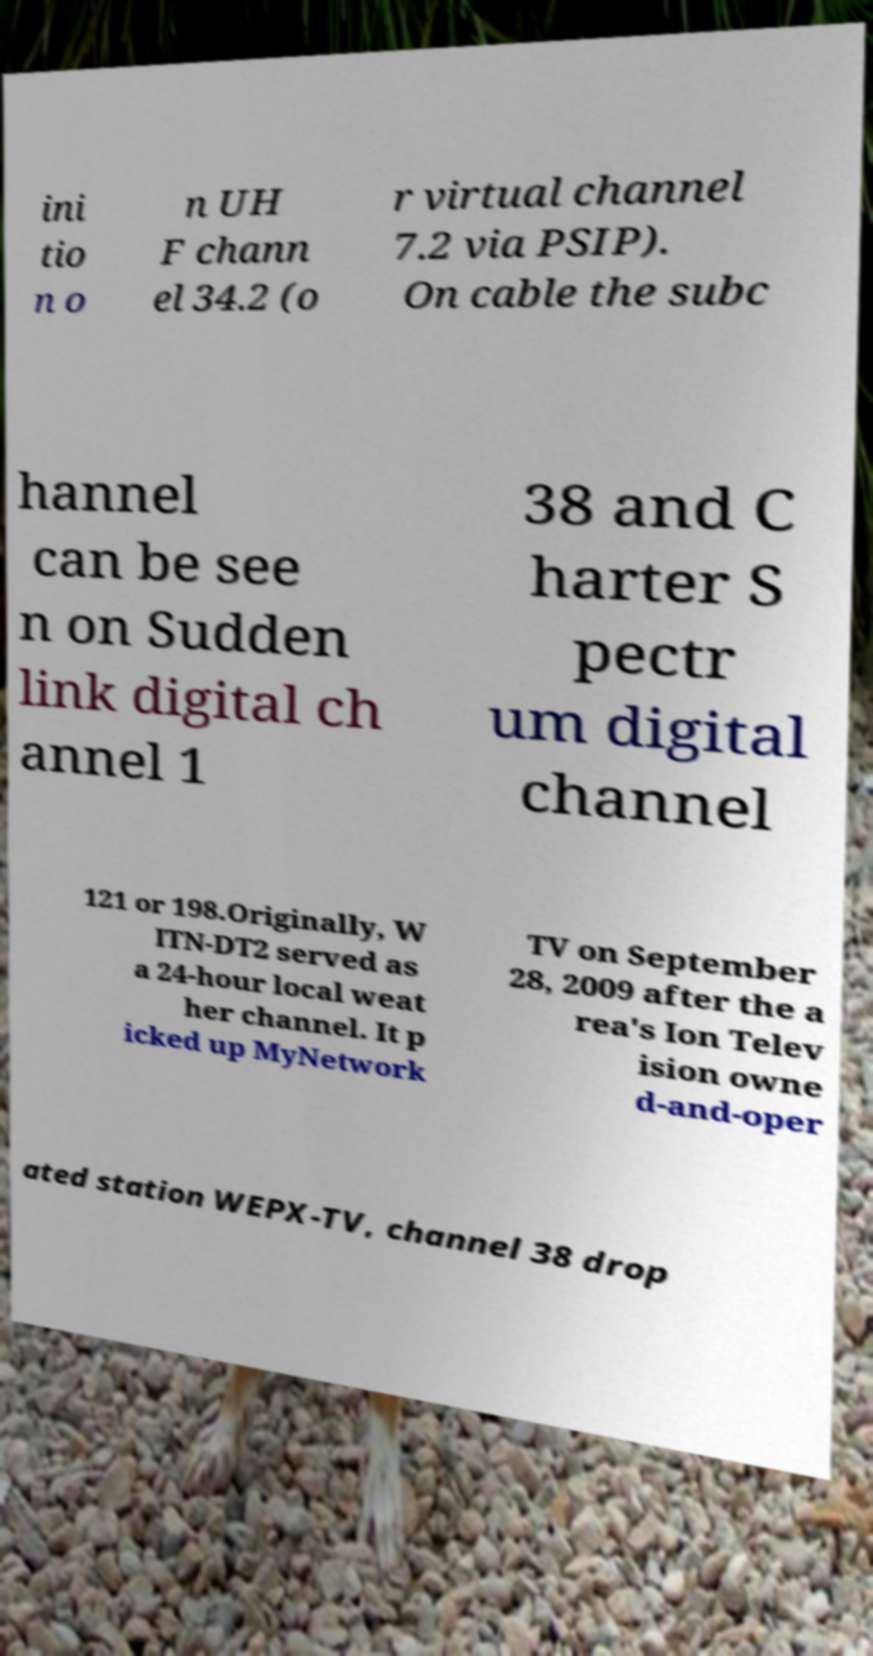Please read and relay the text visible in this image. What does it say? ini tio n o n UH F chann el 34.2 (o r virtual channel 7.2 via PSIP). On cable the subc hannel can be see n on Sudden link digital ch annel 1 38 and C harter S pectr um digital channel 121 or 198.Originally, W ITN-DT2 served as a 24-hour local weat her channel. It p icked up MyNetwork TV on September 28, 2009 after the a rea's Ion Telev ision owne d-and-oper ated station WEPX-TV, channel 38 drop 